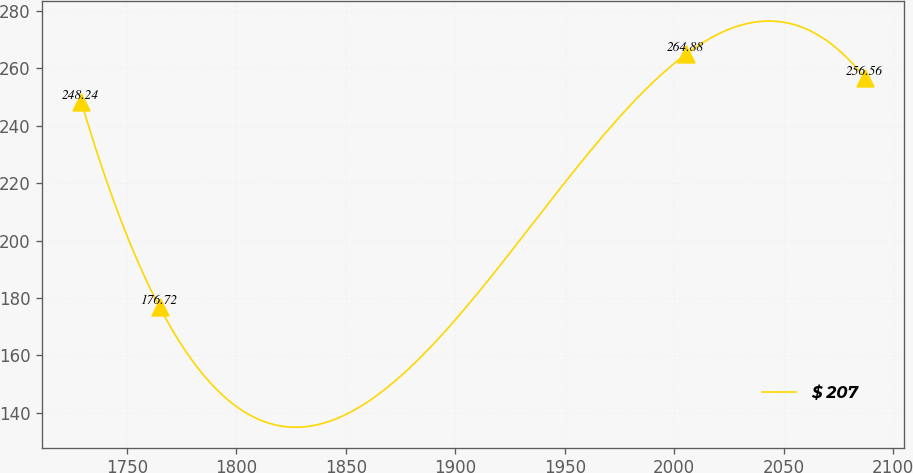Convert chart. <chart><loc_0><loc_0><loc_500><loc_500><line_chart><ecel><fcel>$ 207<nl><fcel>1729.2<fcel>248.24<nl><fcel>1765<fcel>176.72<nl><fcel>2005.42<fcel>264.88<nl><fcel>2087.18<fcel>256.56<nl></chart> 